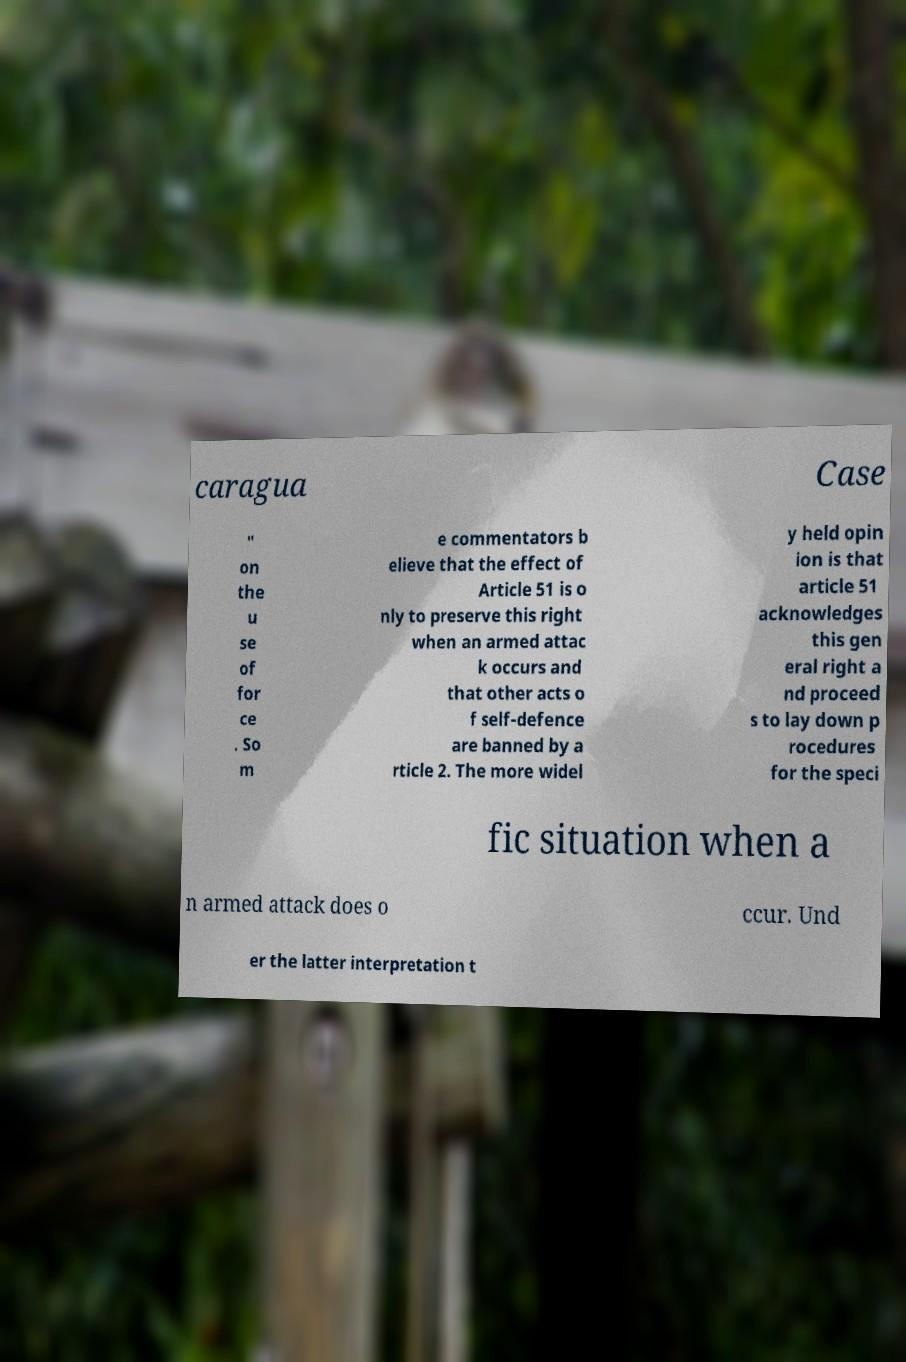There's text embedded in this image that I need extracted. Can you transcribe it verbatim? caragua Case " on the u se of for ce . So m e commentators b elieve that the effect of Article 51 is o nly to preserve this right when an armed attac k occurs and that other acts o f self-defence are banned by a rticle 2. The more widel y held opin ion is that article 51 acknowledges this gen eral right a nd proceed s to lay down p rocedures for the speci fic situation when a n armed attack does o ccur. Und er the latter interpretation t 